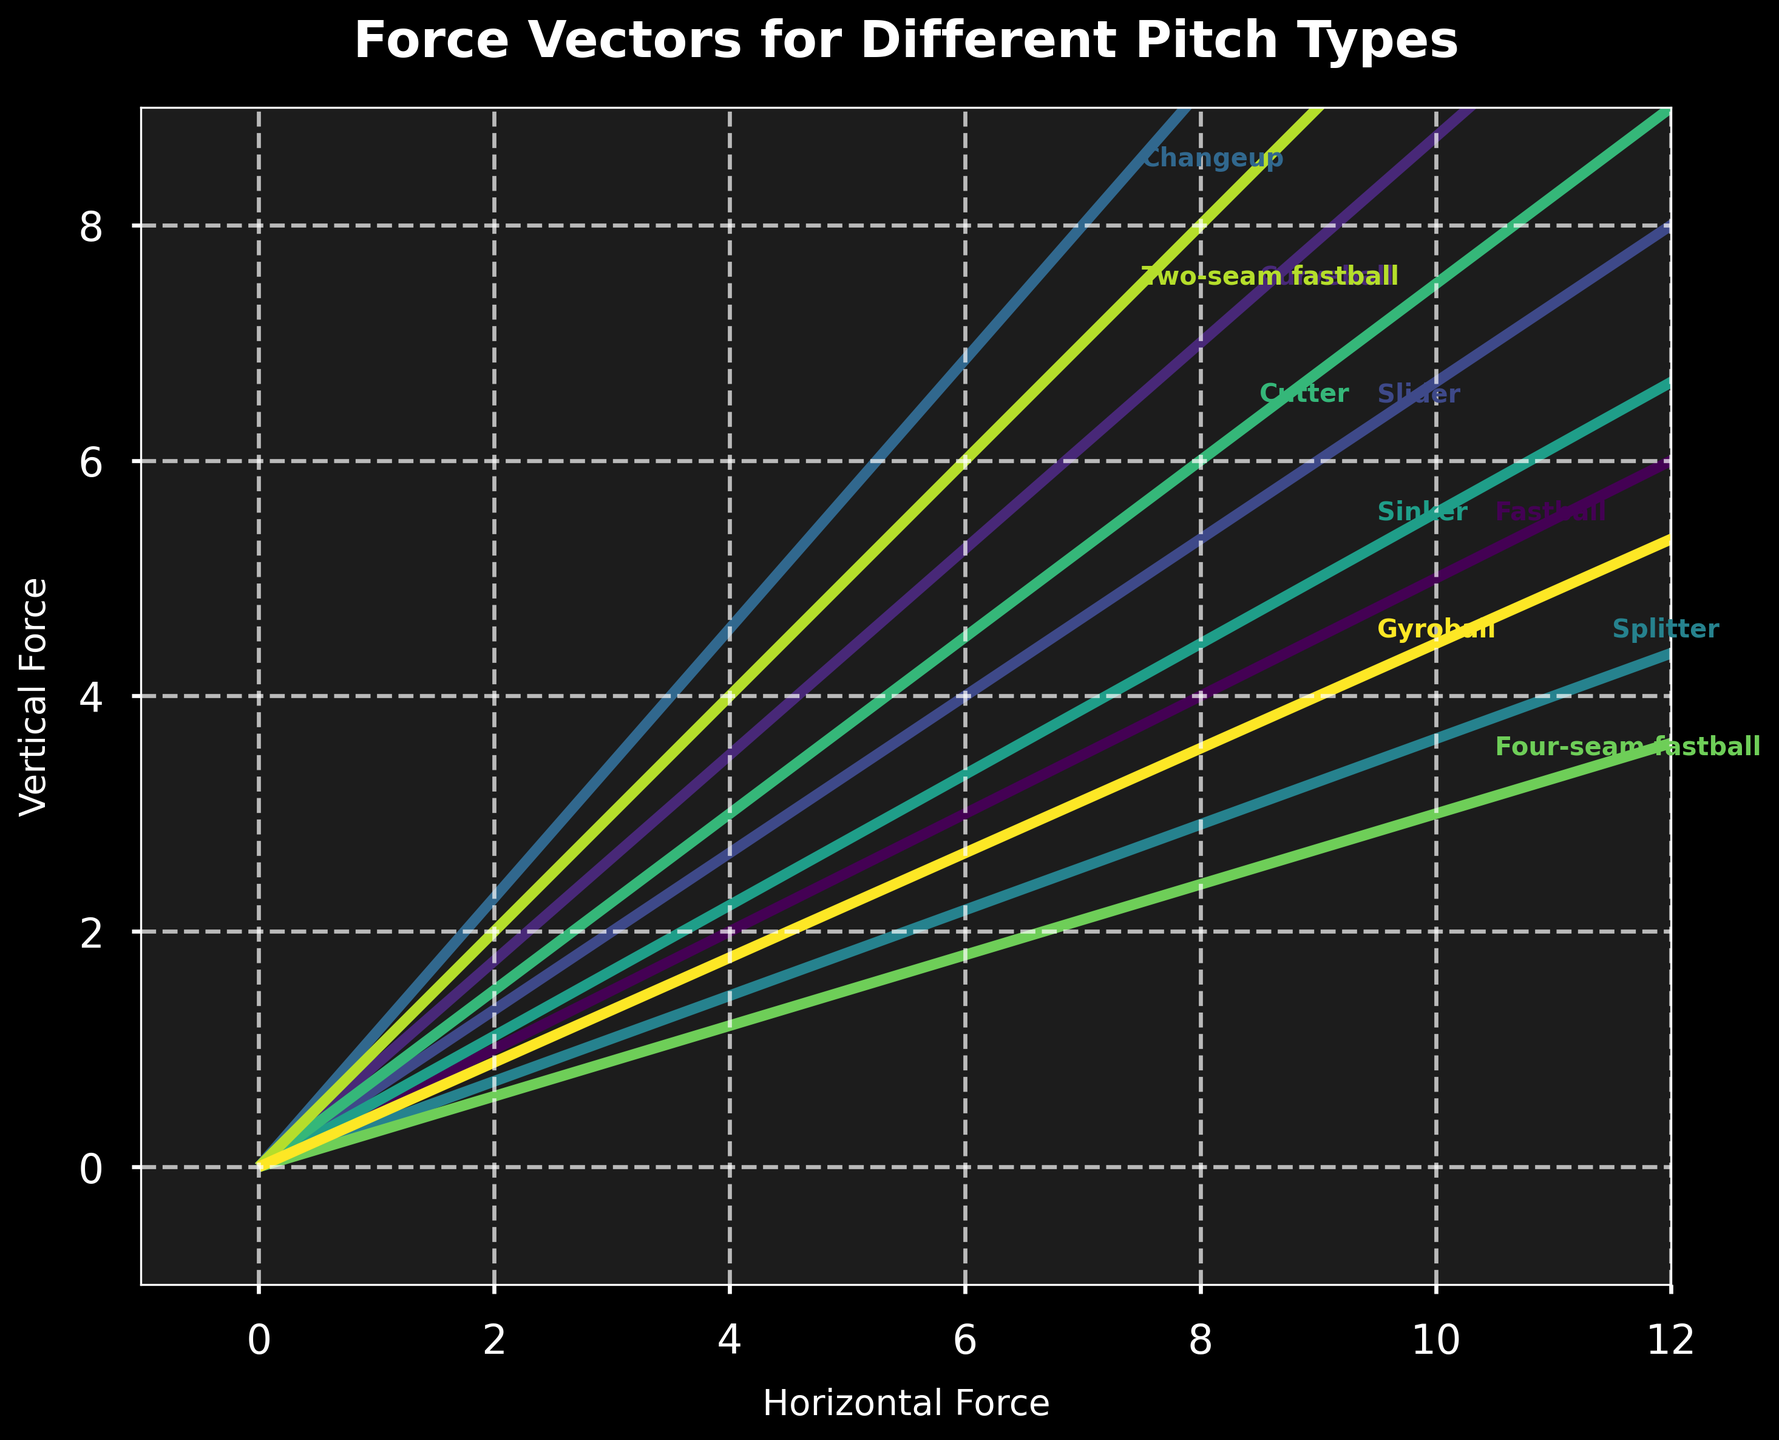What is the title of the figure? The title is usually placed at the top of the figure and is designed to describe the main topic or data being visualized. By looking at the top center area of the plot, you can find the title.
Answer: Force Vectors for Different Pitch Types How many different pitch types are shown in the figure? Each pitch type is represented by a different vector starting from the origin, and the total number of vectors indicates the number of pitch types. By counting the different labeled arrows, you can determine the number of pitch types.
Answer: 10 Which pitch type has the highest horizontal force? The horizontal force is represented by the 'u' component of the vectors. By comparing the lengths of the arrows along the x-axis, the pitch with the longest arrow in the horizontal direction has the highest horizontal force.
Answer: Splitter What is the range of the vertical forces among the pitches? The vertical force is represented by the 'v' component of the vectors. By comparing the smallest and largest vertical force values indicated by their positions along the y-axis, you can determine the range.
Answer: 3 to 8 Which pitch type has the lowest combination of horizontal and vertical force? To find the pitch type with the lowest combination of horizontal (u) and vertical (v) forces, you need to compare the magnitudes of the vectors, which can be estimated from the lengths of the arrows starting from the origin.
Answer: Changeup How does the vertical force of the Curveball compare to that of the Slider? By looking at the position of the arrows labeled as Curveball and Slider along the vertical axis (y-axis), you can compare the vertical components (v) of their forces.
Answer: Curveball has a higher vertical force than Slider What is the average horizontal force for all the pitches? Add up all the horizontal force (u) components and then divide by the number of pitch types to get the average. (10 + 8 + 9 + 7 + 11 + 9 + 8 + 10 + 7 + 9) / 10 = 88 / 10 = 8.8
Answer: 8.8 Which pitch type has the most downward force? The downward force is indicated by the negative 'w' component. By checking the magnitude of the 'w' values in the negative direction, the pitch type with the most negative value indicates the strongest downward force.
Answer: Changeup Which two pitch types have the most similar force vectors? Identify vectors that have similar lengths and directions by visually comparing the arrows starting from the origin and their respective labels.
Answer: Fastball and Four-seam fastball What's the total horizontal force exerted by all the fastball types mentioned? Add the horizontal forces of all fastball-types: Fastball (10), Four-seam fastball (10), Two-seam fastball (7). 10 + 10 + 7 = 27
Answer: 27 